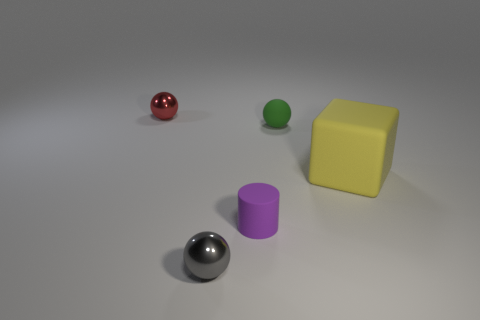What number of small objects are made of the same material as the green sphere?
Offer a very short reply. 1. There is a green matte thing that is the same shape as the gray metal object; what size is it?
Offer a terse response. Small. Is the size of the matte cube the same as the purple thing?
Offer a very short reply. No. What shape is the small thing left of the small metal thing that is in front of the metallic object behind the tiny purple rubber cylinder?
Keep it short and to the point. Sphere. What color is the other small metal object that is the same shape as the gray object?
Offer a terse response. Red. There is a thing that is behind the small gray shiny object and in front of the big yellow rubber cube; what size is it?
Provide a short and direct response. Small. What number of green objects are in front of the metal sphere that is in front of the metallic thing that is behind the small gray metal ball?
Give a very brief answer. 0. What number of large things are gray metal cylinders or yellow things?
Offer a very short reply. 1. Do the tiny ball to the right of the small purple cylinder and the big yellow object have the same material?
Your response must be concise. Yes. What is the tiny ball that is in front of the yellow rubber block right of the tiny shiny object in front of the green matte ball made of?
Your answer should be very brief. Metal. 